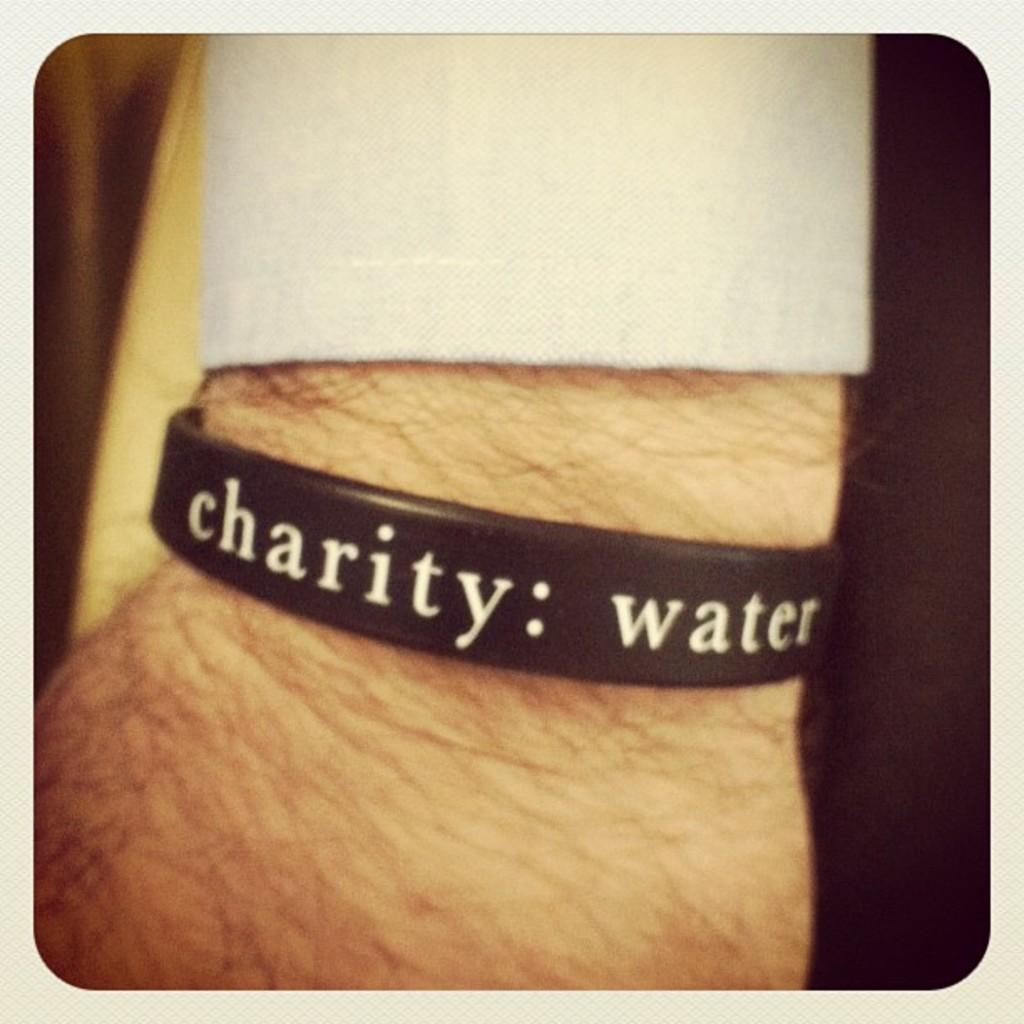What is the overall color scheme of the image? The background of the image is dark. What can be seen in the middle of the image? There is a person's hand in the middle of the image. What is on the hand? The hand has a wrist band on it. What is written on the wrist band? There is text on the wrist band. What type of blood is being sold at the market in the image? There is no market or blood present in the image; it only features a person's hand with a wrist band. What discovery is being made by the person in the image? There is no indication of a discovery being made in the image; it only shows a person's hand with a wrist band. 